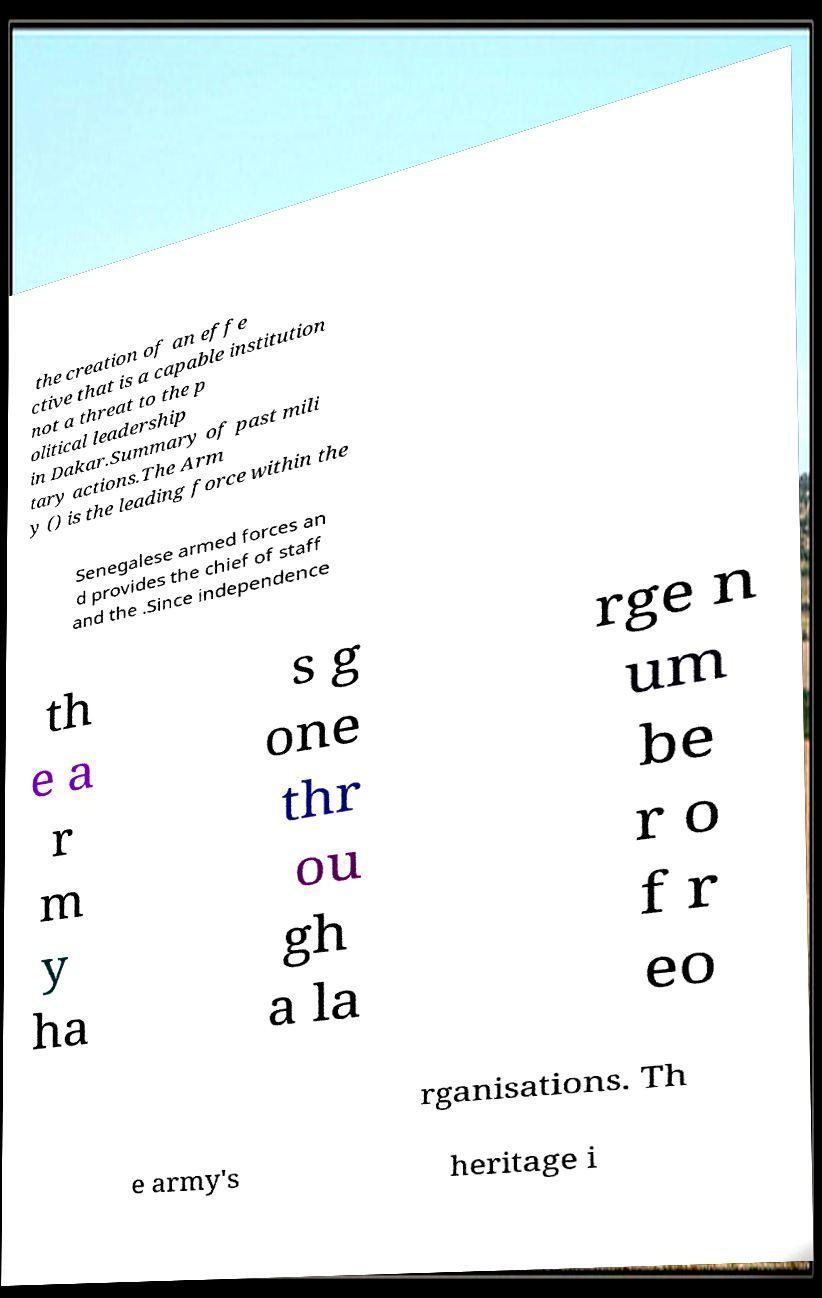Please identify and transcribe the text found in this image. the creation of an effe ctive that is a capable institution not a threat to the p olitical leadership in Dakar.Summary of past mili tary actions.The Arm y () is the leading force within the Senegalese armed forces an d provides the chief of staff and the .Since independence th e a r m y ha s g one thr ou gh a la rge n um be r o f r eo rganisations. Th e army's heritage i 